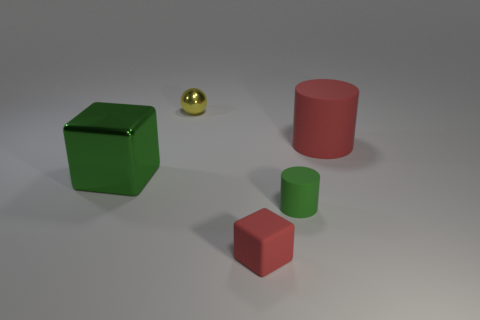There is a green cylinder; does it have the same size as the metallic object in front of the red cylinder?
Give a very brief answer. No. There is a metallic thing in front of the red rubber thing that is behind the tiny thing in front of the small green cylinder; what size is it?
Offer a terse response. Large. What number of large metallic things are right of the small metallic sphere?
Ensure brevity in your answer.  0. The cube that is left of the red thing in front of the red cylinder is made of what material?
Offer a terse response. Metal. Do the yellow metal object and the green block have the same size?
Give a very brief answer. No. How many things are matte things behind the red rubber cube or big objects on the right side of the large green metallic thing?
Offer a very short reply. 2. Is the number of metallic objects that are behind the large red thing greater than the number of large purple shiny objects?
Your response must be concise. Yes. What number of other things are there of the same shape as the big rubber thing?
Provide a succinct answer. 1. The thing that is behind the green rubber thing and right of the tiny red matte block is made of what material?
Offer a terse response. Rubber. How many objects are large shiny things or tiny balls?
Give a very brief answer. 2. 